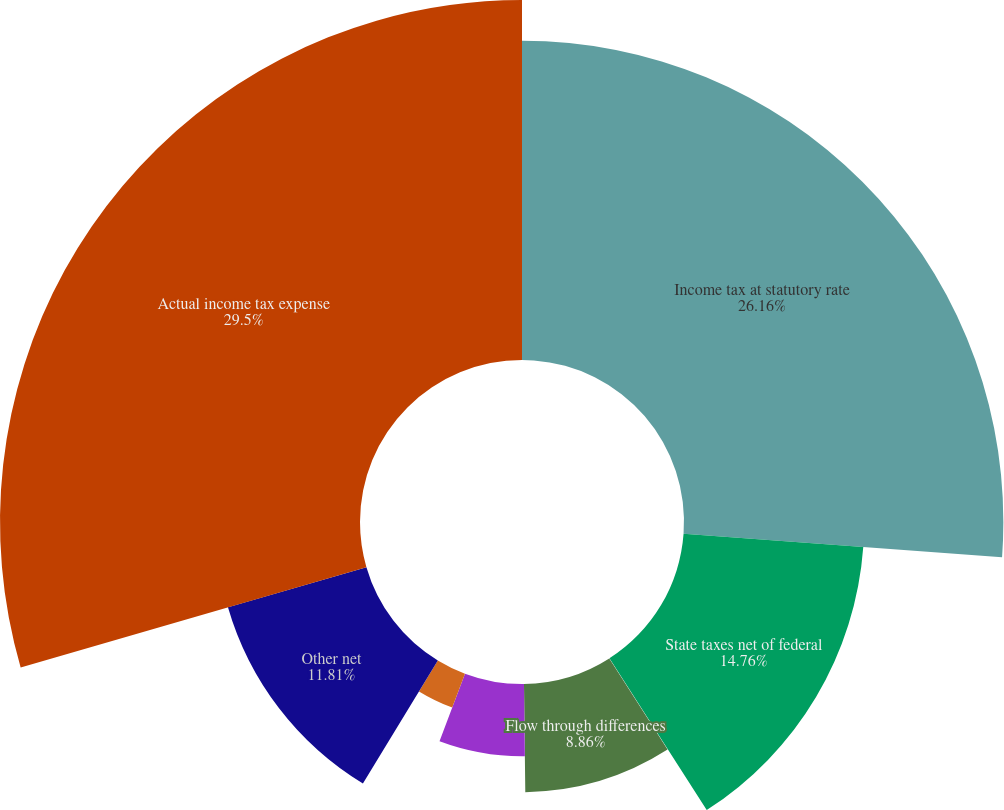Convert chart to OTSL. <chart><loc_0><loc_0><loc_500><loc_500><pie_chart><fcel>Income tax at statutory rate<fcel>State taxes net of federal<fcel>Change in valuation allowance<fcel>Flow through differences<fcel>Amortization of deferred<fcel>Subsidiary preferred dividends<fcel>Other net<fcel>Actual income tax expense<nl><fcel>26.16%<fcel>14.76%<fcel>0.02%<fcel>8.86%<fcel>5.92%<fcel>2.97%<fcel>11.81%<fcel>29.49%<nl></chart> 